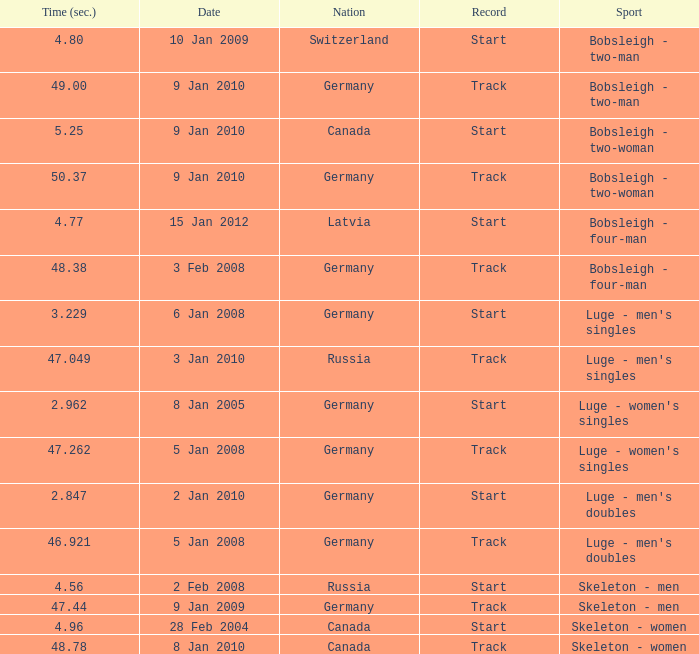Which nation finished with a time of 47.049? Russia. Can you give me this table as a dict? {'header': ['Time (sec.)', 'Date', 'Nation', 'Record', 'Sport'], 'rows': [['4.80', '10 Jan 2009', 'Switzerland', 'Start', 'Bobsleigh - two-man'], ['49.00', '9 Jan 2010', 'Germany', 'Track', 'Bobsleigh - two-man'], ['5.25', '9 Jan 2010', 'Canada', 'Start', 'Bobsleigh - two-woman'], ['50.37', '9 Jan 2010', 'Germany', 'Track', 'Bobsleigh - two-woman'], ['4.77', '15 Jan 2012', 'Latvia', 'Start', 'Bobsleigh - four-man'], ['48.38', '3 Feb 2008', 'Germany', 'Track', 'Bobsleigh - four-man'], ['3.229', '6 Jan 2008', 'Germany', 'Start', "Luge - men's singles"], ['47.049', '3 Jan 2010', 'Russia', 'Track', "Luge - men's singles"], ['2.962', '8 Jan 2005', 'Germany', 'Start', "Luge - women's singles"], ['47.262', '5 Jan 2008', 'Germany', 'Track', "Luge - women's singles"], ['2.847', '2 Jan 2010', 'Germany', 'Start', "Luge - men's doubles"], ['46.921', '5 Jan 2008', 'Germany', 'Track', "Luge - men's doubles"], ['4.56', '2 Feb 2008', 'Russia', 'Start', 'Skeleton - men'], ['47.44', '9 Jan 2009', 'Germany', 'Track', 'Skeleton - men'], ['4.96', '28 Feb 2004', 'Canada', 'Start', 'Skeleton - women'], ['48.78', '8 Jan 2010', 'Canada', 'Track', 'Skeleton - women']]} 